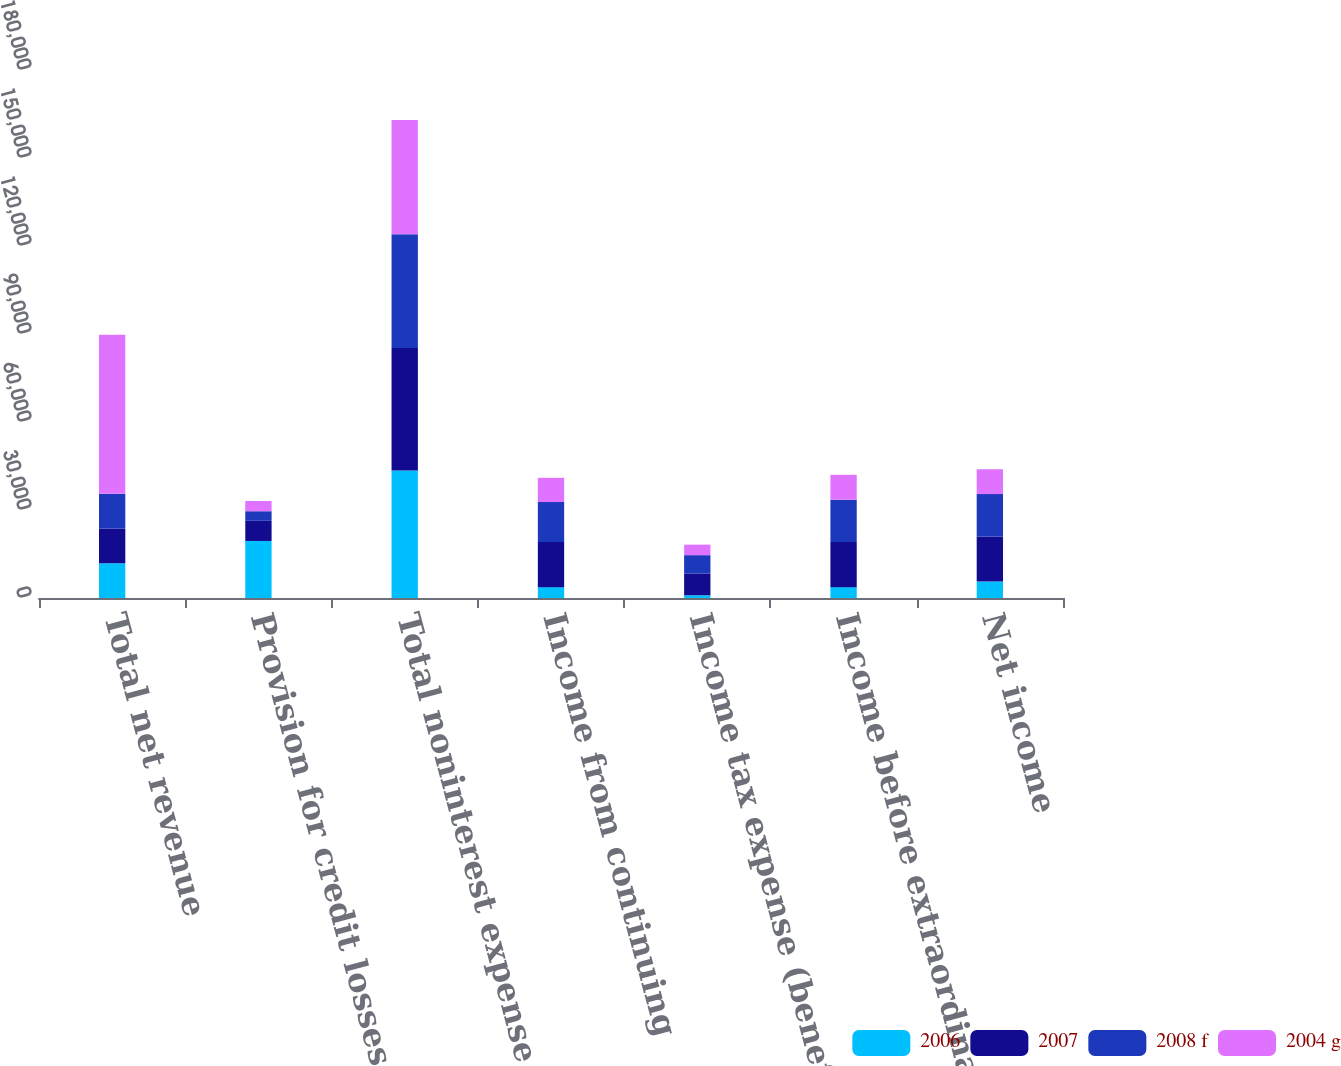Convert chart. <chart><loc_0><loc_0><loc_500><loc_500><stacked_bar_chart><ecel><fcel>Total net revenue<fcel>Provision for credit losses<fcel>Total noninterest expense<fcel>Income from continuing<fcel>Income tax expense (benefit)<fcel>Income before extraordinary<fcel>Net income<nl><fcel>2006<fcel>11839<fcel>19445<fcel>43500<fcel>3699<fcel>926<fcel>3699<fcel>5605<nl><fcel>2007<fcel>11839<fcel>6864<fcel>41703<fcel>15365<fcel>7440<fcel>15365<fcel>15365<nl><fcel>2008 f<fcel>11839<fcel>3270<fcel>38843<fcel>13649<fcel>6237<fcel>14444<fcel>14444<nl><fcel>2004 g<fcel>54248<fcel>3483<fcel>38926<fcel>8254<fcel>3585<fcel>8483<fcel>8483<nl></chart> 